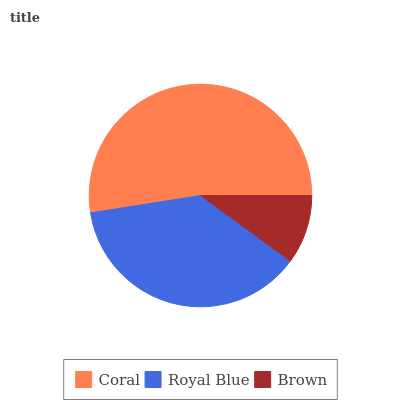Is Brown the minimum?
Answer yes or no. Yes. Is Coral the maximum?
Answer yes or no. Yes. Is Royal Blue the minimum?
Answer yes or no. No. Is Royal Blue the maximum?
Answer yes or no. No. Is Coral greater than Royal Blue?
Answer yes or no. Yes. Is Royal Blue less than Coral?
Answer yes or no. Yes. Is Royal Blue greater than Coral?
Answer yes or no. No. Is Coral less than Royal Blue?
Answer yes or no. No. Is Royal Blue the high median?
Answer yes or no. Yes. Is Royal Blue the low median?
Answer yes or no. Yes. Is Coral the high median?
Answer yes or no. No. Is Coral the low median?
Answer yes or no. No. 